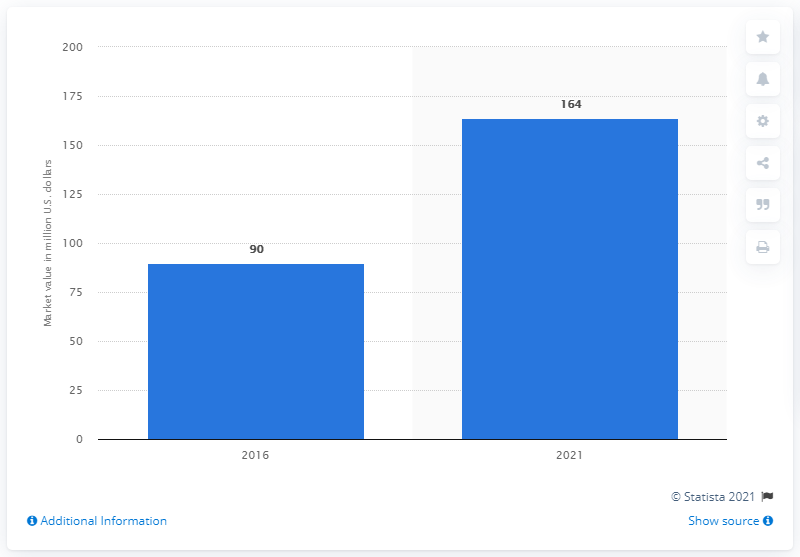Identify some key points in this picture. The global full body scanner market is projected to reach a value of approximately 164 by 2025. 